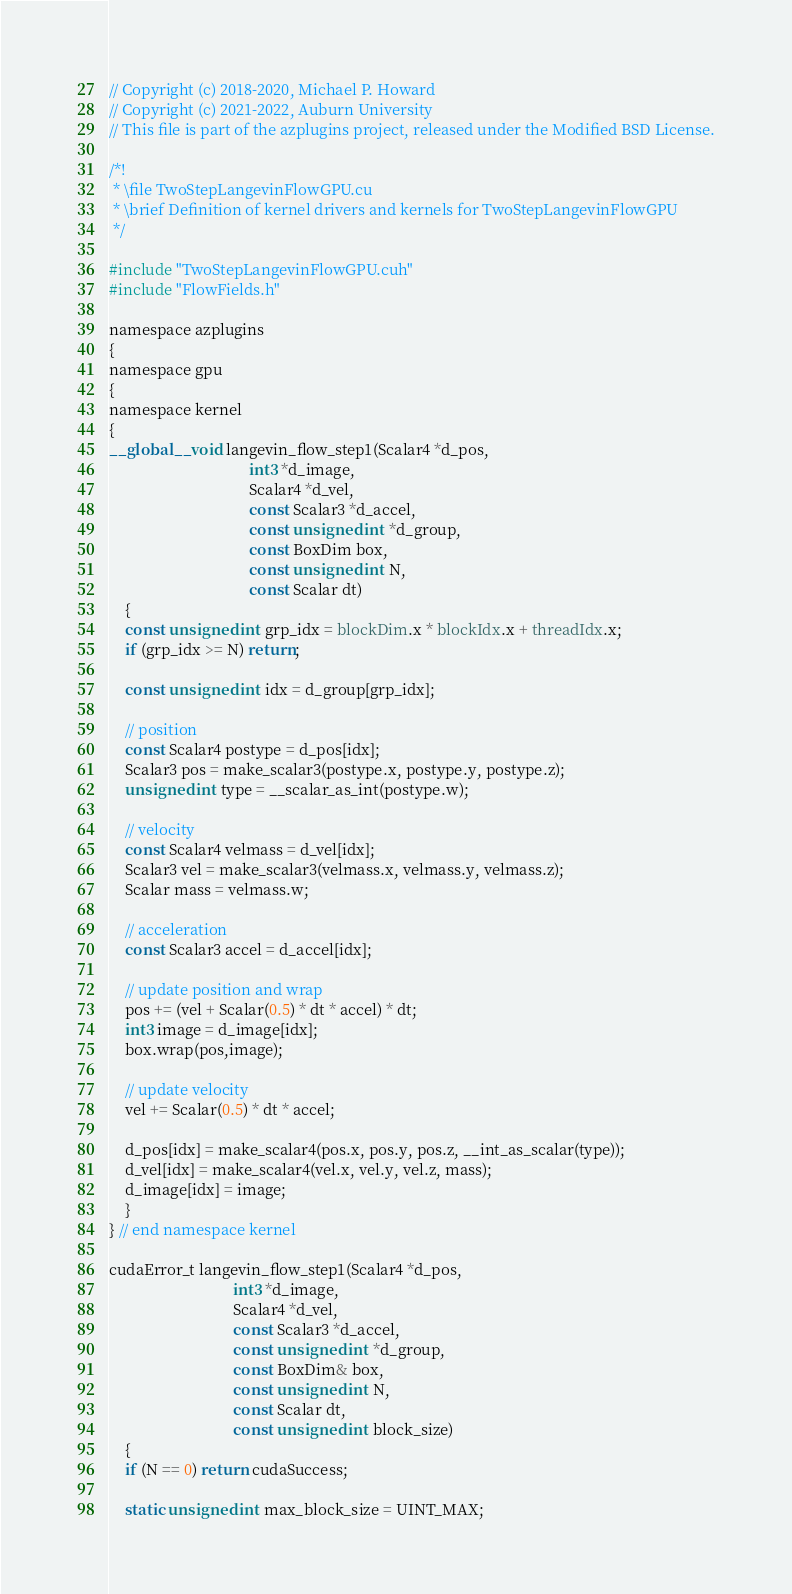Convert code to text. <code><loc_0><loc_0><loc_500><loc_500><_Cuda_>// Copyright (c) 2018-2020, Michael P. Howard
// Copyright (c) 2021-2022, Auburn University
// This file is part of the azplugins project, released under the Modified BSD License.

/*!
 * \file TwoStepLangevinFlowGPU.cu
 * \brief Definition of kernel drivers and kernels for TwoStepLangevinFlowGPU
 */

#include "TwoStepLangevinFlowGPU.cuh"
#include "FlowFields.h"

namespace azplugins
{
namespace gpu
{
namespace kernel
{
__global__ void langevin_flow_step1(Scalar4 *d_pos,
                                    int3 *d_image,
                                    Scalar4 *d_vel,
                                    const Scalar3 *d_accel,
                                    const unsigned int *d_group,
                                    const BoxDim box,
                                    const unsigned int N,
                                    const Scalar dt)
    {
    const unsigned int grp_idx = blockDim.x * blockIdx.x + threadIdx.x;
    if (grp_idx >= N) return;

    const unsigned int idx = d_group[grp_idx];

    // position
    const Scalar4 postype = d_pos[idx];
    Scalar3 pos = make_scalar3(postype.x, postype.y, postype.z);
    unsigned int type = __scalar_as_int(postype.w);

    // velocity
    const Scalar4 velmass = d_vel[idx];
    Scalar3 vel = make_scalar3(velmass.x, velmass.y, velmass.z);
    Scalar mass = velmass.w;

    // acceleration
    const Scalar3 accel = d_accel[idx];

    // update position and wrap
    pos += (vel + Scalar(0.5) * dt * accel) * dt;
    int3 image = d_image[idx];
    box.wrap(pos,image);

    // update velocity
    vel += Scalar(0.5) * dt * accel;

    d_pos[idx] = make_scalar4(pos.x, pos.y, pos.z, __int_as_scalar(type));
    d_vel[idx] = make_scalar4(vel.x, vel.y, vel.z, mass);
    d_image[idx] = image;
    }
} // end namespace kernel

cudaError_t langevin_flow_step1(Scalar4 *d_pos,
                                int3 *d_image,
                                Scalar4 *d_vel,
                                const Scalar3 *d_accel,
                                const unsigned int *d_group,
                                const BoxDim& box,
                                const unsigned int N,
                                const Scalar dt,
                                const unsigned int block_size)
    {
    if (N == 0) return cudaSuccess;

    static unsigned int max_block_size = UINT_MAX;</code> 